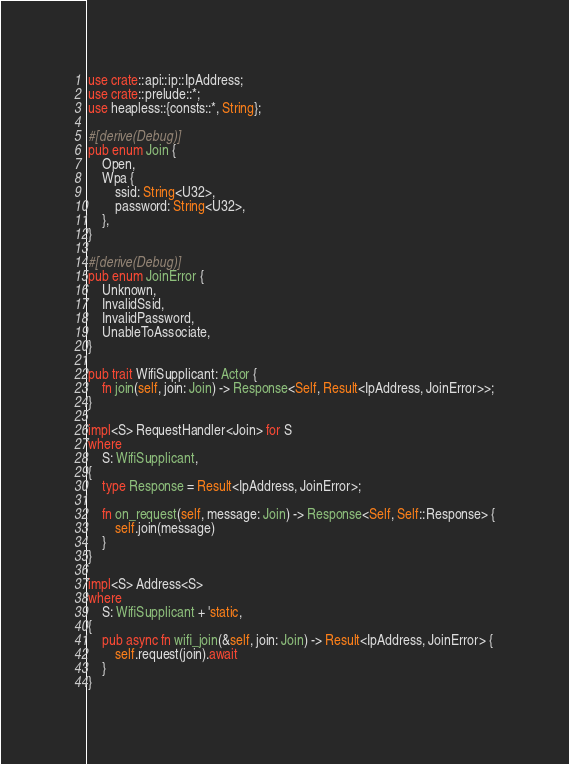Convert code to text. <code><loc_0><loc_0><loc_500><loc_500><_Rust_>use crate::api::ip::IpAddress;
use crate::prelude::*;
use heapless::{consts::*, String};

#[derive(Debug)]
pub enum Join {
    Open,
    Wpa {
        ssid: String<U32>,
        password: String<U32>,
    },
}

#[derive(Debug)]
pub enum JoinError {
    Unknown,
    InvalidSsid,
    InvalidPassword,
    UnableToAssociate,
}

pub trait WifiSupplicant: Actor {
    fn join(self, join: Join) -> Response<Self, Result<IpAddress, JoinError>>;
}

impl<S> RequestHandler<Join> for S
where
    S: WifiSupplicant,
{
    type Response = Result<IpAddress, JoinError>;

    fn on_request(self, message: Join) -> Response<Self, Self::Response> {
        self.join(message)
    }
}

impl<S> Address<S>
where
    S: WifiSupplicant + 'static,
{
    pub async fn wifi_join(&self, join: Join) -> Result<IpAddress, JoinError> {
        self.request(join).await
    }
}
</code> 